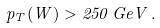<formula> <loc_0><loc_0><loc_500><loc_500>p _ { T } ( W ) > 2 5 0 \, G e V \, .</formula> 